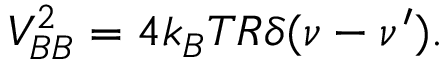Convert formula to latex. <formula><loc_0><loc_0><loc_500><loc_500>V _ { B B } ^ { 2 } = 4 k _ { B } T R \delta ( \nu - \nu ^ { \prime } ) .</formula> 